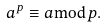<formula> <loc_0><loc_0><loc_500><loc_500>a ^ { p } \equiv a { \bmod { p } } .</formula> 